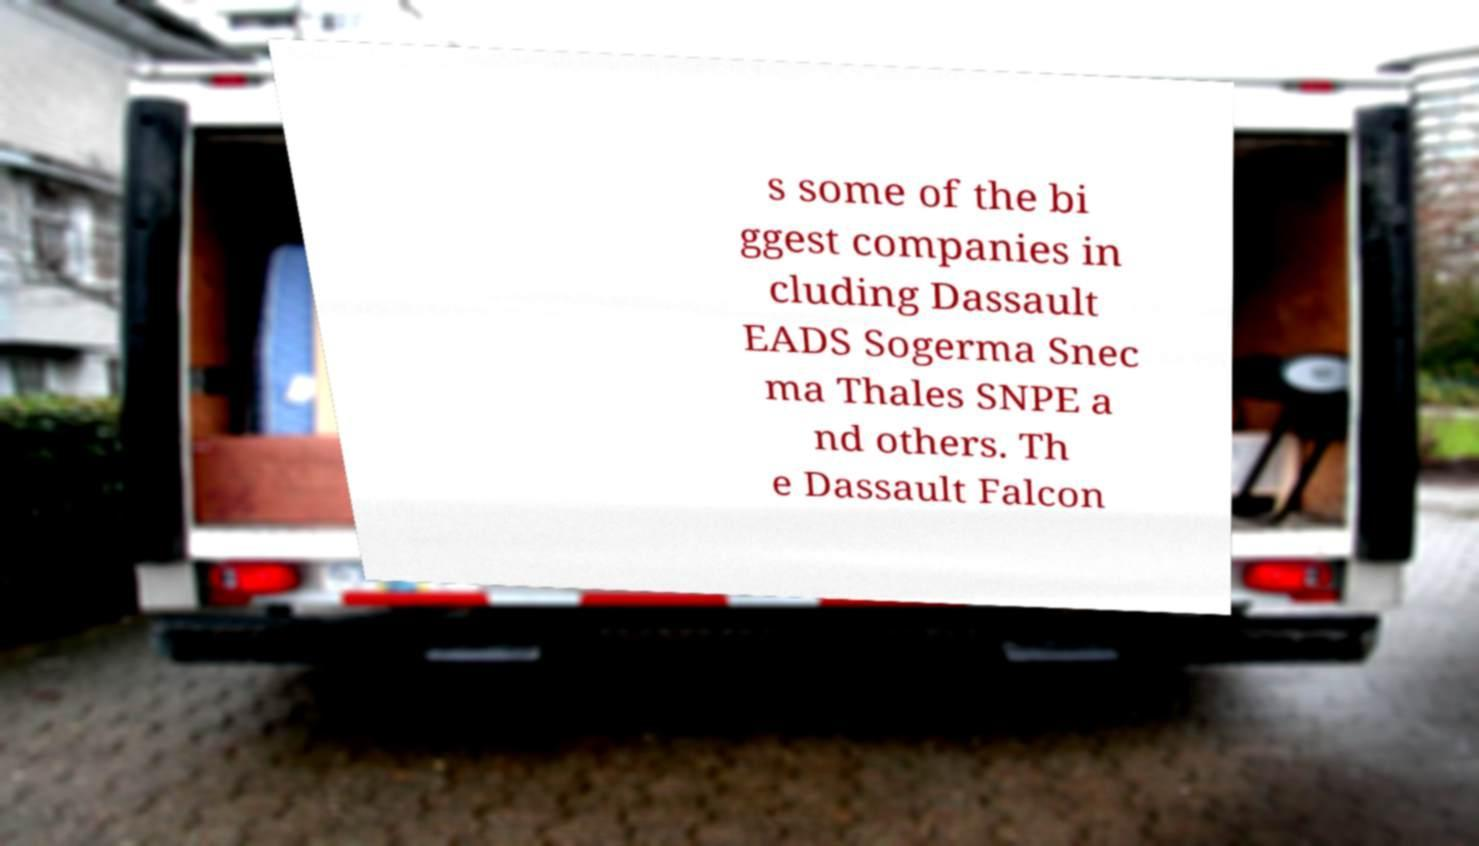What messages or text are displayed in this image? I need them in a readable, typed format. s some of the bi ggest companies in cluding Dassault EADS Sogerma Snec ma Thales SNPE a nd others. Th e Dassault Falcon 